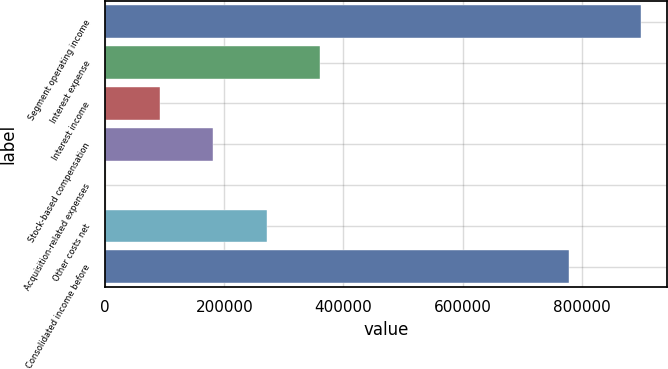Convert chart to OTSL. <chart><loc_0><loc_0><loc_500><loc_500><bar_chart><fcel>Segment operating income<fcel>Interest expense<fcel>Interest income<fcel>Stock-based compensation<fcel>Acquisition-related expenses<fcel>Other costs net<fcel>Consolidated income before<nl><fcel>899205<fcel>360882<fcel>91720.5<fcel>181441<fcel>2000<fcel>271162<fcel>778841<nl></chart> 